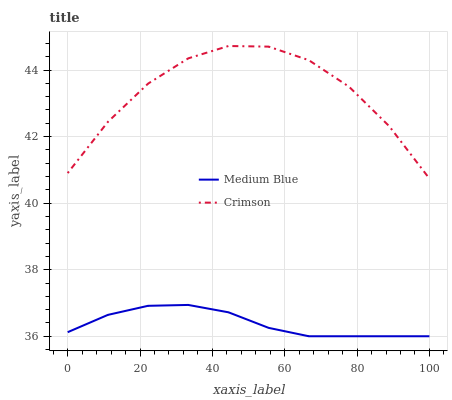Does Medium Blue have the maximum area under the curve?
Answer yes or no. No. Is Medium Blue the roughest?
Answer yes or no. No. Does Medium Blue have the highest value?
Answer yes or no. No. Is Medium Blue less than Crimson?
Answer yes or no. Yes. Is Crimson greater than Medium Blue?
Answer yes or no. Yes. Does Medium Blue intersect Crimson?
Answer yes or no. No. 